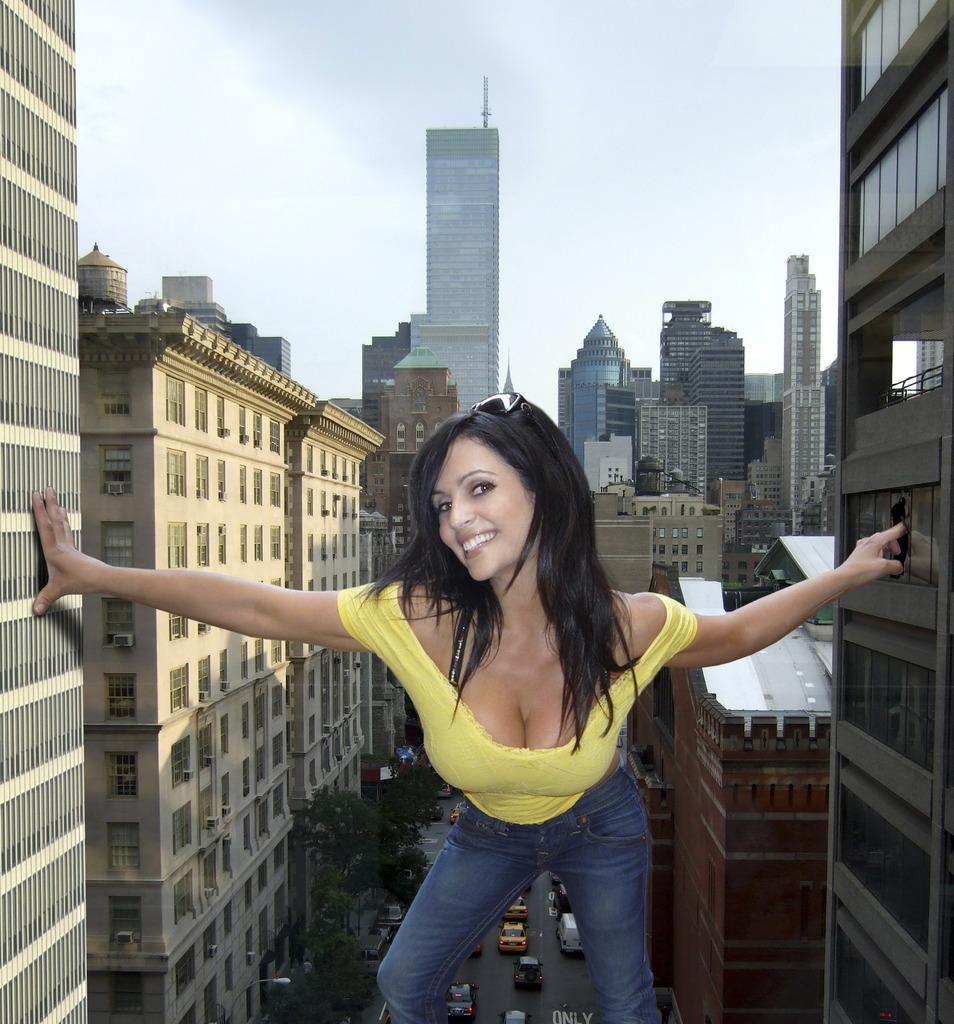Who is present in the image? There is a woman in the image. What is the woman's expression? The woman is smiling. What type of structures can be seen in the image? There are buildings in the image. What other natural elements are present in the image? There are trees in the image. What type of transportation is visible in the image? There are vehicles on the road in the image. What can be seen in the background of the image? The sky is visible in the background of the image. What type of worm can be seen crawling on the woman's shoulder in the image? There is no worm present in the image; it only features a woman, buildings, trees, vehicles, and the sky. 